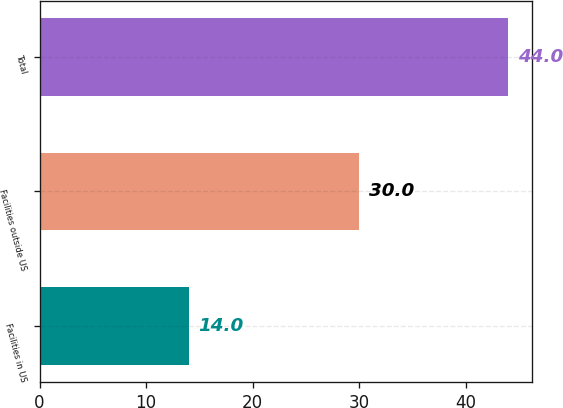Convert chart to OTSL. <chart><loc_0><loc_0><loc_500><loc_500><bar_chart><fcel>Facilities in US<fcel>Facilities outside US<fcel>Total<nl><fcel>14<fcel>30<fcel>44<nl></chart> 